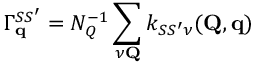Convert formula to latex. <formula><loc_0><loc_0><loc_500><loc_500>\Gamma _ { q } ^ { S S ^ { \prime } } = N _ { Q } ^ { - 1 } \sum _ { \nu Q } k _ { S S ^ { \prime } \nu } ( Q , q )</formula> 